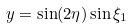<formula> <loc_0><loc_0><loc_500><loc_500>y = \sin ( 2 \eta ) \sin \xi _ { 1 }</formula> 